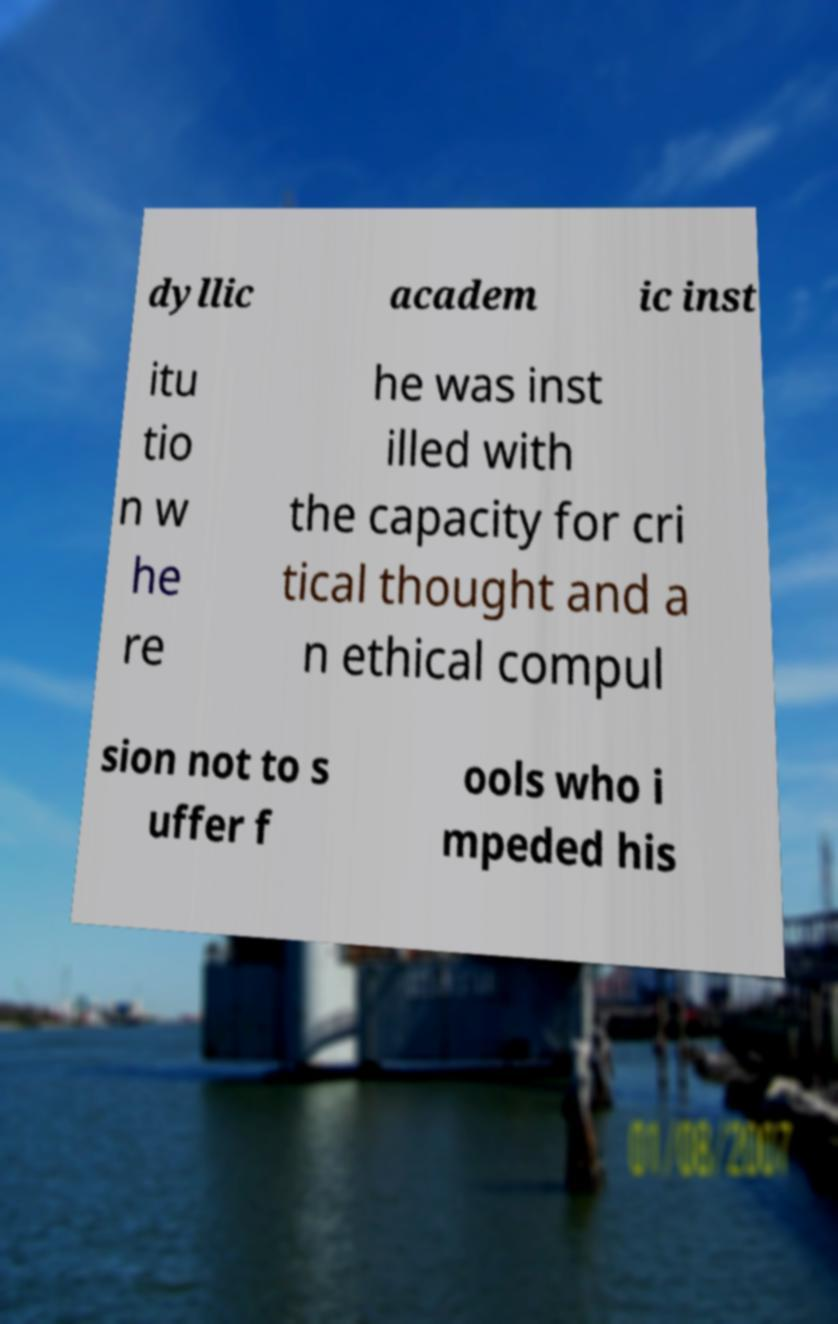Please read and relay the text visible in this image. What does it say? dyllic academ ic inst itu tio n w he re he was inst illed with the capacity for cri tical thought and a n ethical compul sion not to s uffer f ools who i mpeded his 